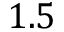Convert formula to latex. <formula><loc_0><loc_0><loc_500><loc_500>1 . 5</formula> 